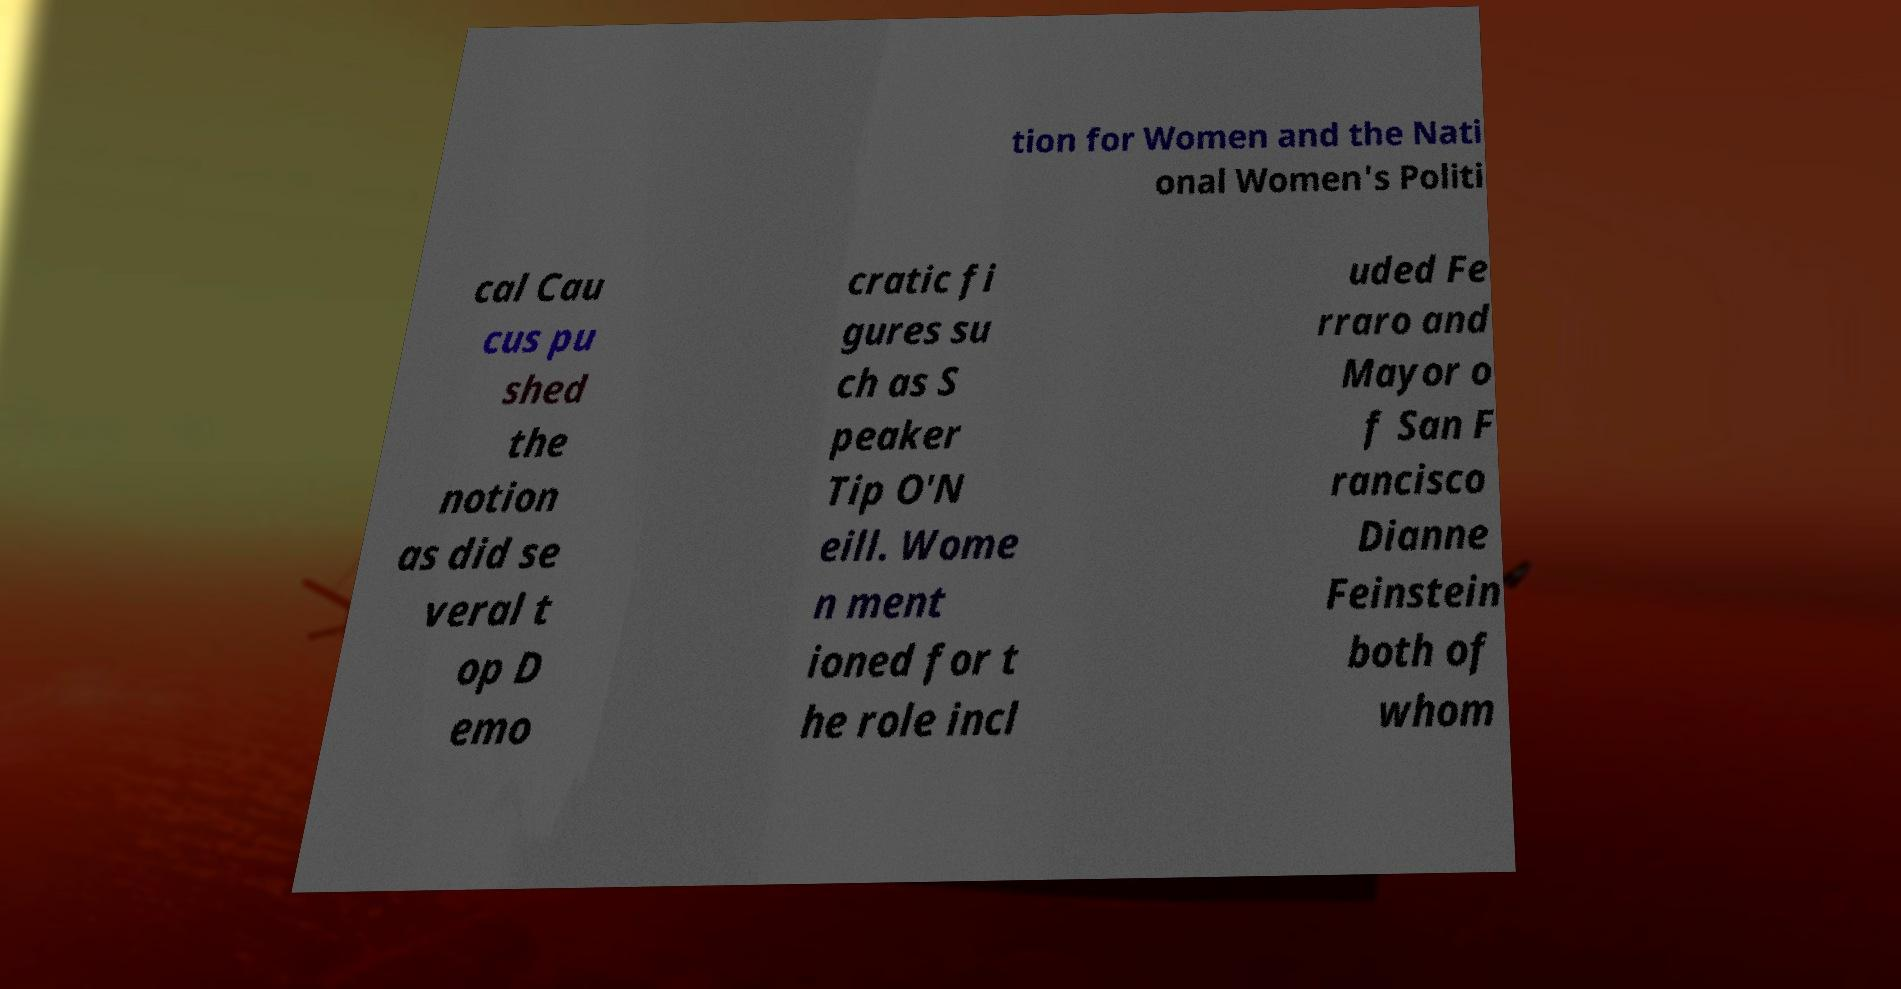Could you assist in decoding the text presented in this image and type it out clearly? tion for Women and the Nati onal Women's Politi cal Cau cus pu shed the notion as did se veral t op D emo cratic fi gures su ch as S peaker Tip O'N eill. Wome n ment ioned for t he role incl uded Fe rraro and Mayor o f San F rancisco Dianne Feinstein both of whom 